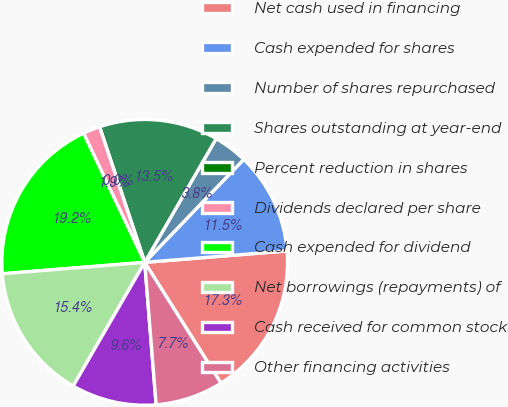<chart> <loc_0><loc_0><loc_500><loc_500><pie_chart><fcel>Net cash used in financing<fcel>Cash expended for shares<fcel>Number of shares repurchased<fcel>Shares outstanding at year-end<fcel>Percent reduction in shares<fcel>Dividends declared per share<fcel>Cash expended for dividend<fcel>Net borrowings (repayments) of<fcel>Cash received for common stock<fcel>Other financing activities<nl><fcel>17.31%<fcel>11.54%<fcel>3.85%<fcel>13.46%<fcel>0.0%<fcel>1.92%<fcel>19.23%<fcel>15.38%<fcel>9.62%<fcel>7.69%<nl></chart> 